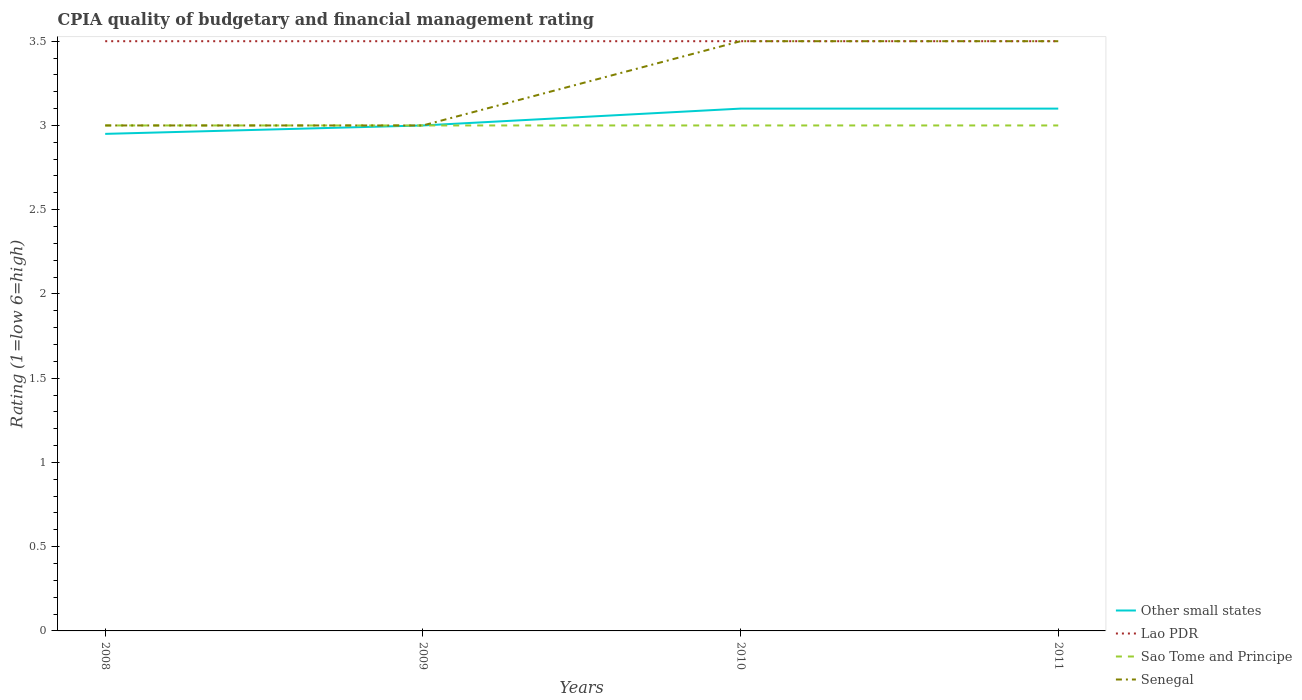How many different coloured lines are there?
Your answer should be very brief. 4. Does the line corresponding to Other small states intersect with the line corresponding to Sao Tome and Principe?
Keep it short and to the point. Yes. Is the number of lines equal to the number of legend labels?
Provide a succinct answer. Yes. Across all years, what is the maximum CPIA rating in Sao Tome and Principe?
Ensure brevity in your answer.  3. In which year was the CPIA rating in Sao Tome and Principe maximum?
Offer a very short reply. 2008. What is the difference between the highest and the second highest CPIA rating in Senegal?
Your response must be concise. 0.5. Is the CPIA rating in Lao PDR strictly greater than the CPIA rating in Other small states over the years?
Make the answer very short. No. How many lines are there?
Your answer should be very brief. 4. How many years are there in the graph?
Your answer should be very brief. 4. What is the difference between two consecutive major ticks on the Y-axis?
Your response must be concise. 0.5. Are the values on the major ticks of Y-axis written in scientific E-notation?
Your answer should be very brief. No. Does the graph contain any zero values?
Provide a short and direct response. No. Where does the legend appear in the graph?
Your answer should be compact. Bottom right. How are the legend labels stacked?
Your answer should be compact. Vertical. What is the title of the graph?
Keep it short and to the point. CPIA quality of budgetary and financial management rating. Does "European Union" appear as one of the legend labels in the graph?
Make the answer very short. No. What is the label or title of the X-axis?
Your answer should be compact. Years. What is the Rating (1=low 6=high) in Other small states in 2008?
Your answer should be very brief. 2.95. What is the Rating (1=low 6=high) in Sao Tome and Principe in 2008?
Make the answer very short. 3. What is the Rating (1=low 6=high) in Senegal in 2008?
Your answer should be compact. 3. What is the Rating (1=low 6=high) of Other small states in 2010?
Ensure brevity in your answer.  3.1. What is the Rating (1=low 6=high) in Lao PDR in 2010?
Provide a short and direct response. 3.5. What is the Rating (1=low 6=high) of Other small states in 2011?
Provide a short and direct response. 3.1. What is the Rating (1=low 6=high) of Sao Tome and Principe in 2011?
Your answer should be very brief. 3. Across all years, what is the maximum Rating (1=low 6=high) of Other small states?
Your answer should be very brief. 3.1. Across all years, what is the maximum Rating (1=low 6=high) of Sao Tome and Principe?
Offer a terse response. 3. Across all years, what is the minimum Rating (1=low 6=high) in Other small states?
Provide a short and direct response. 2.95. Across all years, what is the minimum Rating (1=low 6=high) in Lao PDR?
Offer a very short reply. 3.5. Across all years, what is the minimum Rating (1=low 6=high) in Senegal?
Offer a terse response. 3. What is the total Rating (1=low 6=high) of Other small states in the graph?
Your response must be concise. 12.15. What is the total Rating (1=low 6=high) in Lao PDR in the graph?
Offer a terse response. 14. What is the difference between the Rating (1=low 6=high) of Lao PDR in 2008 and that in 2009?
Give a very brief answer. 0. What is the difference between the Rating (1=low 6=high) in Sao Tome and Principe in 2008 and that in 2009?
Offer a very short reply. 0. What is the difference between the Rating (1=low 6=high) of Senegal in 2008 and that in 2009?
Offer a terse response. 0. What is the difference between the Rating (1=low 6=high) of Other small states in 2008 and that in 2010?
Offer a terse response. -0.15. What is the difference between the Rating (1=low 6=high) of Lao PDR in 2008 and that in 2010?
Your answer should be very brief. 0. What is the difference between the Rating (1=low 6=high) in Senegal in 2008 and that in 2010?
Keep it short and to the point. -0.5. What is the difference between the Rating (1=low 6=high) of Sao Tome and Principe in 2008 and that in 2011?
Your answer should be very brief. 0. What is the difference between the Rating (1=low 6=high) of Other small states in 2009 and that in 2010?
Offer a terse response. -0.1. What is the difference between the Rating (1=low 6=high) in Lao PDR in 2009 and that in 2010?
Provide a succinct answer. 0. What is the difference between the Rating (1=low 6=high) in Sao Tome and Principe in 2009 and that in 2010?
Provide a succinct answer. 0. What is the difference between the Rating (1=low 6=high) in Lao PDR in 2010 and that in 2011?
Offer a very short reply. 0. What is the difference between the Rating (1=low 6=high) in Sao Tome and Principe in 2010 and that in 2011?
Give a very brief answer. 0. What is the difference between the Rating (1=low 6=high) in Other small states in 2008 and the Rating (1=low 6=high) in Lao PDR in 2009?
Provide a succinct answer. -0.55. What is the difference between the Rating (1=low 6=high) of Sao Tome and Principe in 2008 and the Rating (1=low 6=high) of Senegal in 2009?
Offer a terse response. 0. What is the difference between the Rating (1=low 6=high) of Other small states in 2008 and the Rating (1=low 6=high) of Lao PDR in 2010?
Give a very brief answer. -0.55. What is the difference between the Rating (1=low 6=high) of Other small states in 2008 and the Rating (1=low 6=high) of Sao Tome and Principe in 2010?
Keep it short and to the point. -0.05. What is the difference between the Rating (1=low 6=high) in Other small states in 2008 and the Rating (1=low 6=high) in Senegal in 2010?
Offer a very short reply. -0.55. What is the difference between the Rating (1=low 6=high) in Lao PDR in 2008 and the Rating (1=low 6=high) in Senegal in 2010?
Make the answer very short. 0. What is the difference between the Rating (1=low 6=high) in Sao Tome and Principe in 2008 and the Rating (1=low 6=high) in Senegal in 2010?
Provide a short and direct response. -0.5. What is the difference between the Rating (1=low 6=high) of Other small states in 2008 and the Rating (1=low 6=high) of Lao PDR in 2011?
Provide a succinct answer. -0.55. What is the difference between the Rating (1=low 6=high) in Other small states in 2008 and the Rating (1=low 6=high) in Sao Tome and Principe in 2011?
Provide a succinct answer. -0.05. What is the difference between the Rating (1=low 6=high) in Other small states in 2008 and the Rating (1=low 6=high) in Senegal in 2011?
Your response must be concise. -0.55. What is the difference between the Rating (1=low 6=high) in Lao PDR in 2008 and the Rating (1=low 6=high) in Sao Tome and Principe in 2011?
Ensure brevity in your answer.  0.5. What is the difference between the Rating (1=low 6=high) in Lao PDR in 2008 and the Rating (1=low 6=high) in Senegal in 2011?
Your answer should be very brief. 0. What is the difference between the Rating (1=low 6=high) of Sao Tome and Principe in 2008 and the Rating (1=low 6=high) of Senegal in 2011?
Give a very brief answer. -0.5. What is the difference between the Rating (1=low 6=high) of Other small states in 2009 and the Rating (1=low 6=high) of Sao Tome and Principe in 2010?
Provide a succinct answer. 0. What is the difference between the Rating (1=low 6=high) of Other small states in 2009 and the Rating (1=low 6=high) of Senegal in 2010?
Your answer should be compact. -0.5. What is the difference between the Rating (1=low 6=high) in Sao Tome and Principe in 2009 and the Rating (1=low 6=high) in Senegal in 2010?
Your answer should be compact. -0.5. What is the difference between the Rating (1=low 6=high) of Other small states in 2009 and the Rating (1=low 6=high) of Senegal in 2011?
Your answer should be compact. -0.5. What is the difference between the Rating (1=low 6=high) in Lao PDR in 2009 and the Rating (1=low 6=high) in Sao Tome and Principe in 2011?
Ensure brevity in your answer.  0.5. What is the difference between the Rating (1=low 6=high) in Lao PDR in 2009 and the Rating (1=low 6=high) in Senegal in 2011?
Provide a succinct answer. 0. What is the difference between the Rating (1=low 6=high) in Other small states in 2010 and the Rating (1=low 6=high) in Lao PDR in 2011?
Provide a short and direct response. -0.4. What is the difference between the Rating (1=low 6=high) of Lao PDR in 2010 and the Rating (1=low 6=high) of Senegal in 2011?
Your answer should be very brief. 0. What is the difference between the Rating (1=low 6=high) of Sao Tome and Principe in 2010 and the Rating (1=low 6=high) of Senegal in 2011?
Offer a very short reply. -0.5. What is the average Rating (1=low 6=high) of Other small states per year?
Provide a succinct answer. 3.04. What is the average Rating (1=low 6=high) of Lao PDR per year?
Your answer should be compact. 3.5. In the year 2008, what is the difference between the Rating (1=low 6=high) in Other small states and Rating (1=low 6=high) in Lao PDR?
Your response must be concise. -0.55. In the year 2008, what is the difference between the Rating (1=low 6=high) in Lao PDR and Rating (1=low 6=high) in Sao Tome and Principe?
Ensure brevity in your answer.  0.5. In the year 2008, what is the difference between the Rating (1=low 6=high) of Lao PDR and Rating (1=low 6=high) of Senegal?
Your answer should be very brief. 0.5. In the year 2009, what is the difference between the Rating (1=low 6=high) in Other small states and Rating (1=low 6=high) in Lao PDR?
Offer a terse response. -0.5. In the year 2009, what is the difference between the Rating (1=low 6=high) of Sao Tome and Principe and Rating (1=low 6=high) of Senegal?
Ensure brevity in your answer.  0. In the year 2010, what is the difference between the Rating (1=low 6=high) in Lao PDR and Rating (1=low 6=high) in Sao Tome and Principe?
Your answer should be compact. 0.5. In the year 2010, what is the difference between the Rating (1=low 6=high) of Lao PDR and Rating (1=low 6=high) of Senegal?
Make the answer very short. 0. In the year 2011, what is the difference between the Rating (1=low 6=high) of Lao PDR and Rating (1=low 6=high) of Sao Tome and Principe?
Give a very brief answer. 0.5. In the year 2011, what is the difference between the Rating (1=low 6=high) of Lao PDR and Rating (1=low 6=high) of Senegal?
Offer a very short reply. 0. In the year 2011, what is the difference between the Rating (1=low 6=high) of Sao Tome and Principe and Rating (1=low 6=high) of Senegal?
Your answer should be very brief. -0.5. What is the ratio of the Rating (1=low 6=high) of Other small states in 2008 to that in 2009?
Keep it short and to the point. 0.98. What is the ratio of the Rating (1=low 6=high) in Sao Tome and Principe in 2008 to that in 2009?
Ensure brevity in your answer.  1. What is the ratio of the Rating (1=low 6=high) of Senegal in 2008 to that in 2009?
Offer a very short reply. 1. What is the ratio of the Rating (1=low 6=high) of Other small states in 2008 to that in 2010?
Provide a succinct answer. 0.95. What is the ratio of the Rating (1=low 6=high) of Other small states in 2008 to that in 2011?
Give a very brief answer. 0.95. What is the ratio of the Rating (1=low 6=high) in Sao Tome and Principe in 2008 to that in 2011?
Offer a very short reply. 1. What is the ratio of the Rating (1=low 6=high) in Senegal in 2008 to that in 2011?
Give a very brief answer. 0.86. What is the ratio of the Rating (1=low 6=high) in Other small states in 2009 to that in 2010?
Make the answer very short. 0.97. What is the ratio of the Rating (1=low 6=high) in Lao PDR in 2009 to that in 2010?
Your response must be concise. 1. What is the ratio of the Rating (1=low 6=high) of Sao Tome and Principe in 2009 to that in 2010?
Provide a succinct answer. 1. What is the ratio of the Rating (1=low 6=high) of Lao PDR in 2009 to that in 2011?
Offer a very short reply. 1. What is the ratio of the Rating (1=low 6=high) of Sao Tome and Principe in 2009 to that in 2011?
Offer a very short reply. 1. What is the difference between the highest and the second highest Rating (1=low 6=high) of Other small states?
Provide a succinct answer. 0. What is the difference between the highest and the second highest Rating (1=low 6=high) in Lao PDR?
Offer a very short reply. 0. What is the difference between the highest and the second highest Rating (1=low 6=high) in Senegal?
Ensure brevity in your answer.  0. What is the difference between the highest and the lowest Rating (1=low 6=high) of Other small states?
Ensure brevity in your answer.  0.15. What is the difference between the highest and the lowest Rating (1=low 6=high) in Lao PDR?
Make the answer very short. 0. What is the difference between the highest and the lowest Rating (1=low 6=high) in Sao Tome and Principe?
Your answer should be very brief. 0. What is the difference between the highest and the lowest Rating (1=low 6=high) of Senegal?
Give a very brief answer. 0.5. 